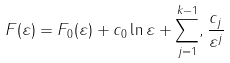Convert formula to latex. <formula><loc_0><loc_0><loc_500><loc_500>F ( \varepsilon ) = F _ { 0 } ( \varepsilon ) + c _ { 0 } \ln \varepsilon + \sum _ { j = 1 } ^ { k - 1 } , \frac { c _ { j } } { \varepsilon ^ { j } }</formula> 